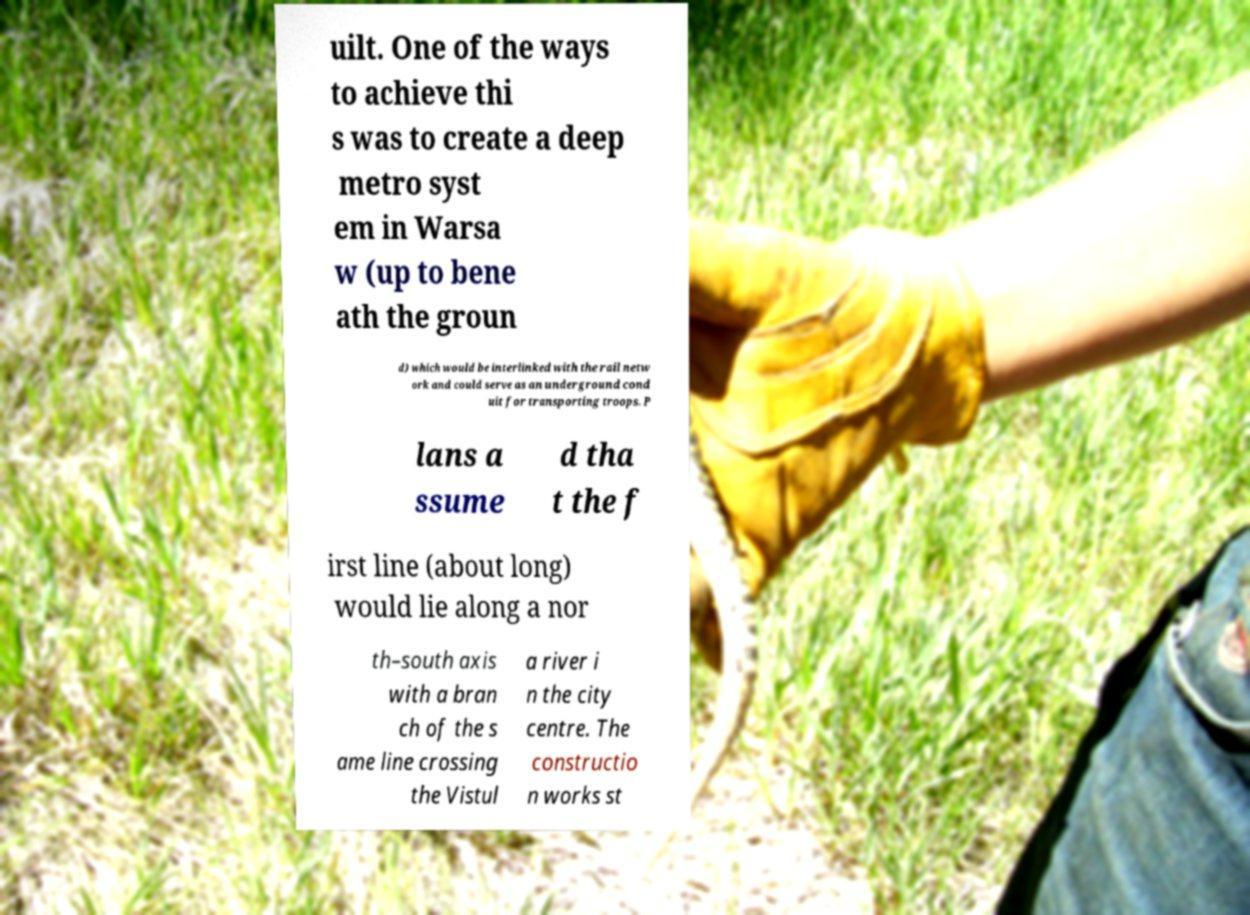Could you assist in decoding the text presented in this image and type it out clearly? uilt. One of the ways to achieve thi s was to create a deep metro syst em in Warsa w (up to bene ath the groun d) which would be interlinked with the rail netw ork and could serve as an underground cond uit for transporting troops. P lans a ssume d tha t the f irst line (about long) would lie along a nor th–south axis with a bran ch of the s ame line crossing the Vistul a river i n the city centre. The constructio n works st 